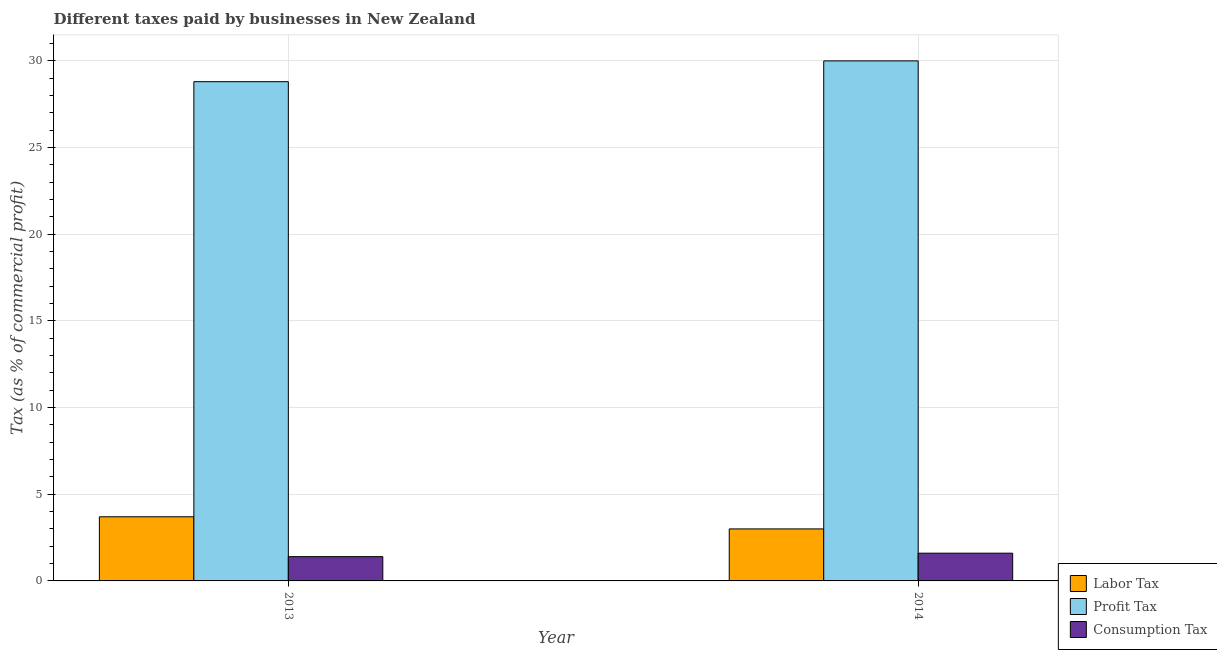Are the number of bars per tick equal to the number of legend labels?
Give a very brief answer. Yes. Are the number of bars on each tick of the X-axis equal?
Your response must be concise. Yes. How many bars are there on the 2nd tick from the left?
Provide a succinct answer. 3. How many bars are there on the 1st tick from the right?
Offer a very short reply. 3. What is the label of the 1st group of bars from the left?
Your response must be concise. 2013. What is the percentage of consumption tax in 2014?
Provide a succinct answer. 1.6. Across all years, what is the maximum percentage of profit tax?
Offer a terse response. 30. Across all years, what is the minimum percentage of labor tax?
Make the answer very short. 3. What is the difference between the percentage of consumption tax in 2013 and that in 2014?
Offer a terse response. -0.2. What is the difference between the percentage of profit tax in 2014 and the percentage of labor tax in 2013?
Make the answer very short. 1.2. What is the average percentage of profit tax per year?
Provide a succinct answer. 29.4. What is the ratio of the percentage of consumption tax in 2013 to that in 2014?
Your answer should be compact. 0.87. Is the percentage of labor tax in 2013 less than that in 2014?
Your answer should be very brief. No. In how many years, is the percentage of consumption tax greater than the average percentage of consumption tax taken over all years?
Offer a terse response. 1. What does the 3rd bar from the left in 2014 represents?
Your answer should be very brief. Consumption Tax. What does the 2nd bar from the right in 2013 represents?
Your response must be concise. Profit Tax. How many bars are there?
Provide a succinct answer. 6. Does the graph contain any zero values?
Your response must be concise. No. Does the graph contain grids?
Keep it short and to the point. Yes. How are the legend labels stacked?
Offer a very short reply. Vertical. What is the title of the graph?
Ensure brevity in your answer.  Different taxes paid by businesses in New Zealand. What is the label or title of the X-axis?
Keep it short and to the point. Year. What is the label or title of the Y-axis?
Your answer should be very brief. Tax (as % of commercial profit). What is the Tax (as % of commercial profit) of Profit Tax in 2013?
Your answer should be very brief. 28.8. What is the Tax (as % of commercial profit) in Consumption Tax in 2013?
Provide a short and direct response. 1.4. What is the Tax (as % of commercial profit) in Labor Tax in 2014?
Make the answer very short. 3. Across all years, what is the maximum Tax (as % of commercial profit) of Labor Tax?
Ensure brevity in your answer.  3.7. Across all years, what is the maximum Tax (as % of commercial profit) of Consumption Tax?
Provide a short and direct response. 1.6. Across all years, what is the minimum Tax (as % of commercial profit) in Profit Tax?
Your response must be concise. 28.8. What is the total Tax (as % of commercial profit) in Labor Tax in the graph?
Provide a short and direct response. 6.7. What is the total Tax (as % of commercial profit) in Profit Tax in the graph?
Give a very brief answer. 58.8. What is the total Tax (as % of commercial profit) in Consumption Tax in the graph?
Your answer should be compact. 3. What is the difference between the Tax (as % of commercial profit) of Labor Tax in 2013 and that in 2014?
Make the answer very short. 0.7. What is the difference between the Tax (as % of commercial profit) of Profit Tax in 2013 and that in 2014?
Ensure brevity in your answer.  -1.2. What is the difference between the Tax (as % of commercial profit) of Labor Tax in 2013 and the Tax (as % of commercial profit) of Profit Tax in 2014?
Keep it short and to the point. -26.3. What is the difference between the Tax (as % of commercial profit) of Profit Tax in 2013 and the Tax (as % of commercial profit) of Consumption Tax in 2014?
Give a very brief answer. 27.2. What is the average Tax (as % of commercial profit) of Labor Tax per year?
Provide a succinct answer. 3.35. What is the average Tax (as % of commercial profit) in Profit Tax per year?
Your response must be concise. 29.4. In the year 2013, what is the difference between the Tax (as % of commercial profit) in Labor Tax and Tax (as % of commercial profit) in Profit Tax?
Give a very brief answer. -25.1. In the year 2013, what is the difference between the Tax (as % of commercial profit) of Profit Tax and Tax (as % of commercial profit) of Consumption Tax?
Provide a short and direct response. 27.4. In the year 2014, what is the difference between the Tax (as % of commercial profit) in Labor Tax and Tax (as % of commercial profit) in Profit Tax?
Keep it short and to the point. -27. In the year 2014, what is the difference between the Tax (as % of commercial profit) of Profit Tax and Tax (as % of commercial profit) of Consumption Tax?
Keep it short and to the point. 28.4. What is the ratio of the Tax (as % of commercial profit) of Labor Tax in 2013 to that in 2014?
Provide a short and direct response. 1.23. What is the ratio of the Tax (as % of commercial profit) of Profit Tax in 2013 to that in 2014?
Your response must be concise. 0.96. What is the difference between the highest and the second highest Tax (as % of commercial profit) of Labor Tax?
Your answer should be very brief. 0.7. 